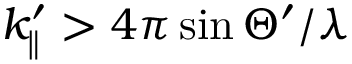<formula> <loc_0><loc_0><loc_500><loc_500>k _ { \| } ^ { \prime } > 4 \pi \sin \Theta ^ { \prime } / \lambda</formula> 